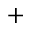Convert formula to latex. <formula><loc_0><loc_0><loc_500><loc_500>^ { + }</formula> 